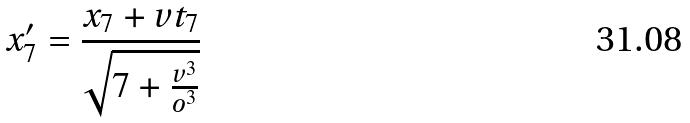<formula> <loc_0><loc_0><loc_500><loc_500>x _ { 7 } ^ { \prime } = \frac { x _ { 7 } + v t _ { 7 } } { \sqrt { 7 + \frac { v ^ { 3 } } { o ^ { 3 } } } }</formula> 